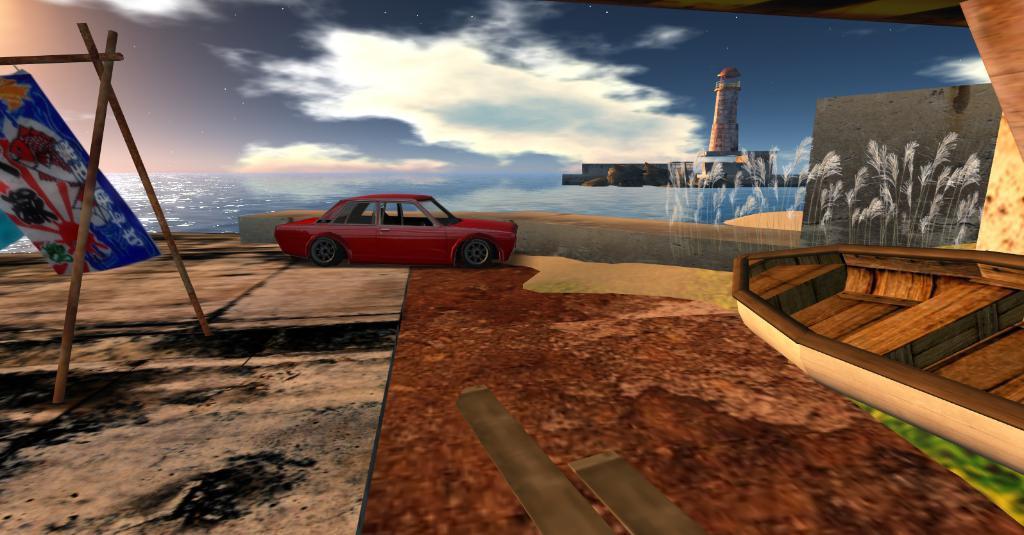Can you describe this image briefly? This is an animated picture. Here we can see a car, banner, wooden sticks, boat, and water. There is a tower. In the background there is sky with clouds. 